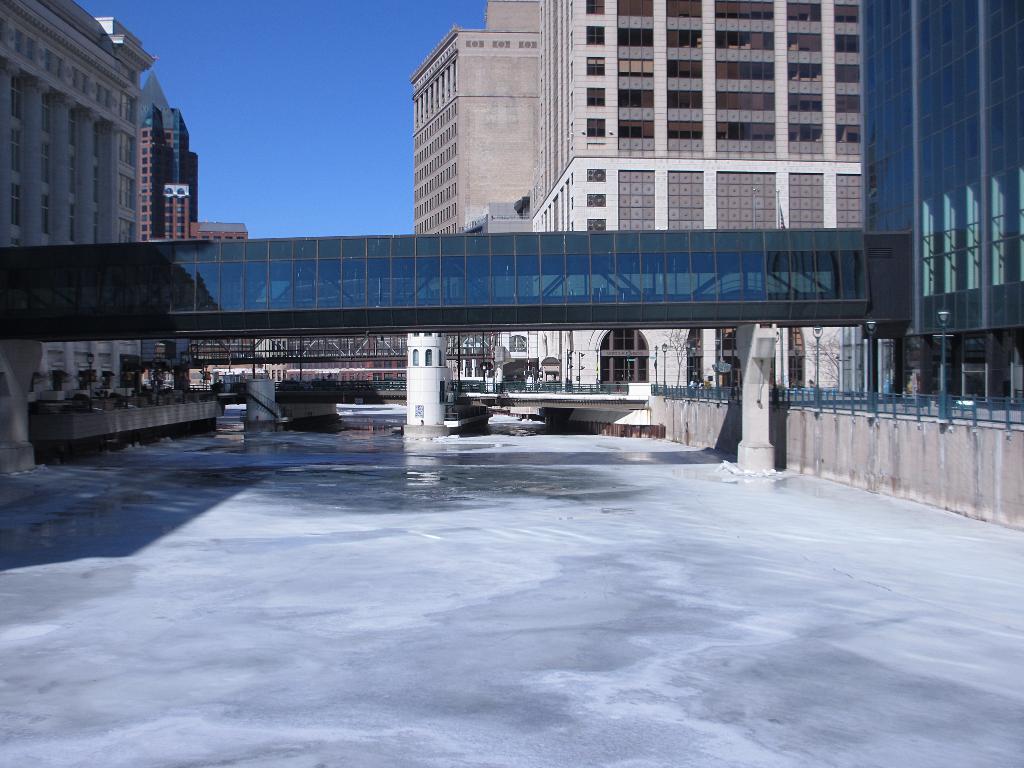Can you describe this image briefly? In this image we can see buildings with windows, bridge, metal fencing and we can also see the sky. 